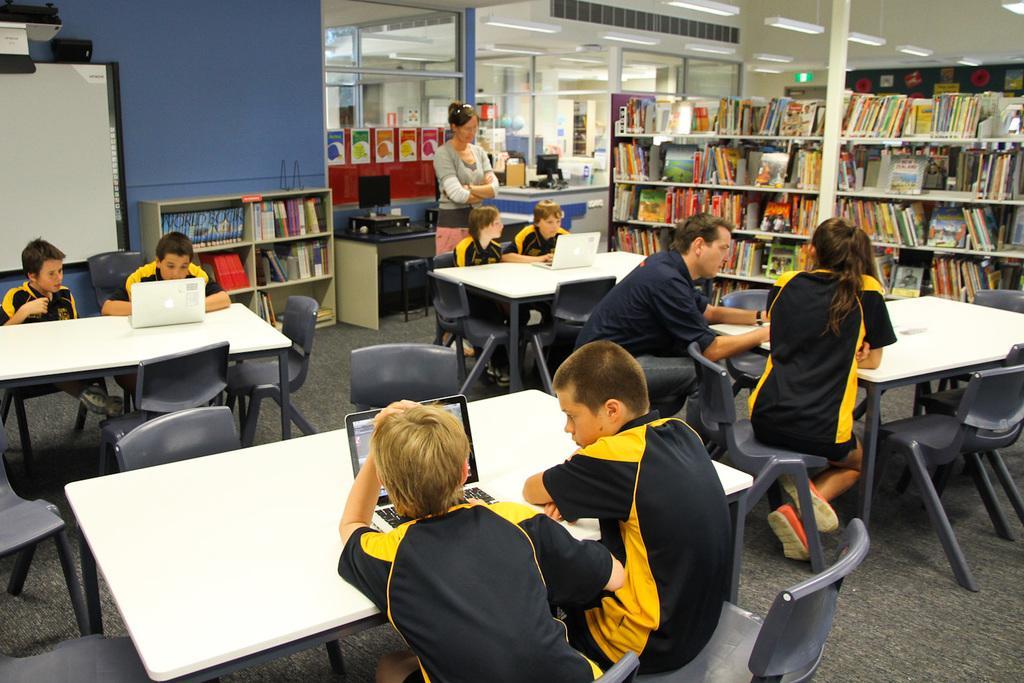Please provide a concise description of this image. In this picture I can see there are few kids sitting here in the chairs and there is a woman standing in the backdrop, also there are some books arranged in the book shelf and in the backdrop there is a blue wall. 